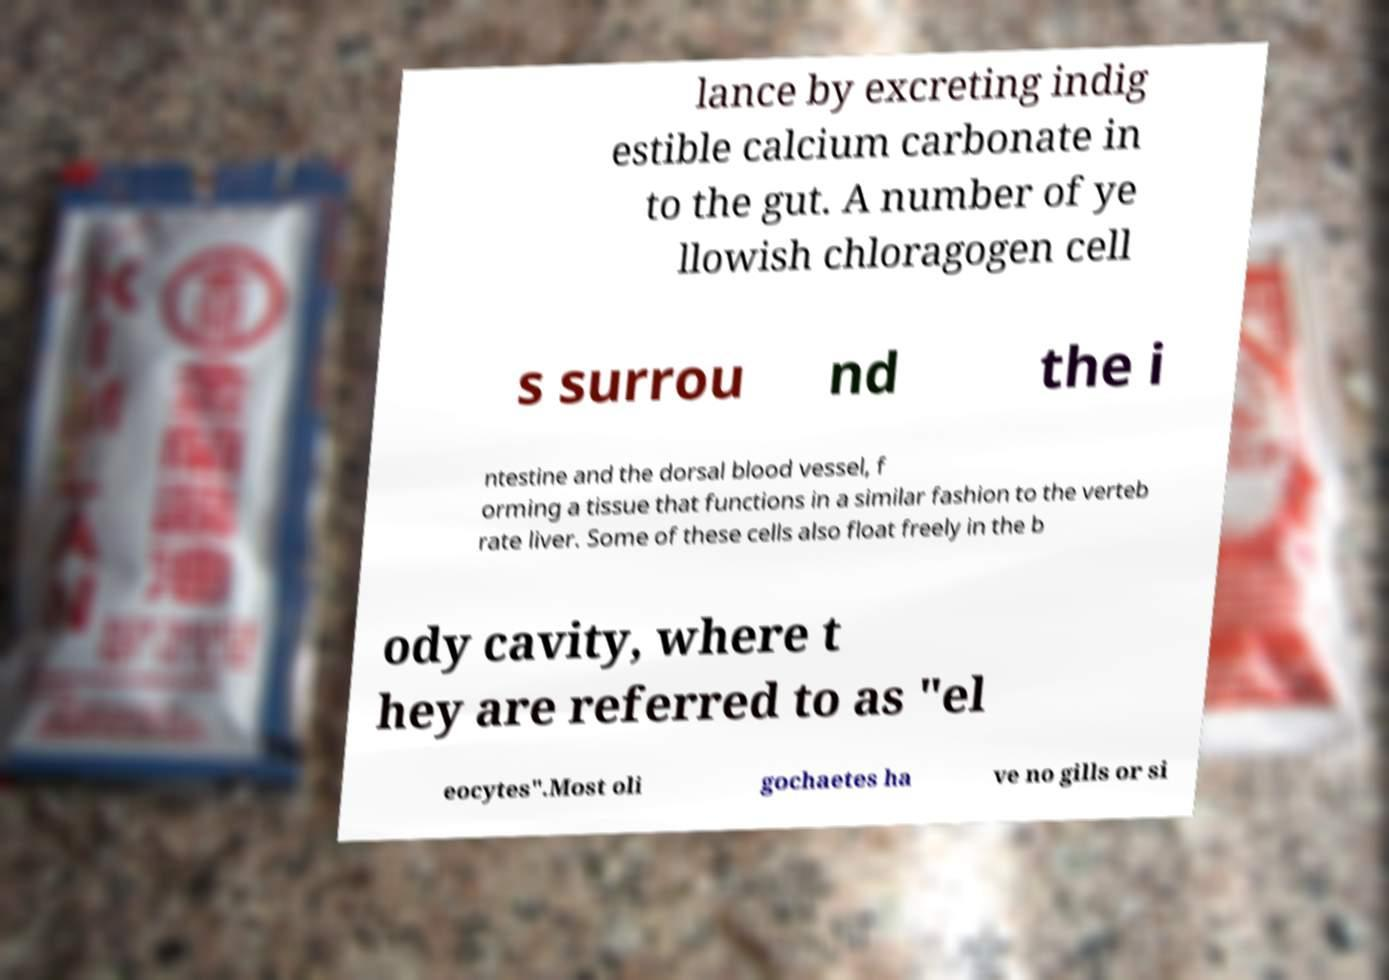I need the written content from this picture converted into text. Can you do that? lance by excreting indig estible calcium carbonate in to the gut. A number of ye llowish chloragogen cell s surrou nd the i ntestine and the dorsal blood vessel, f orming a tissue that functions in a similar fashion to the verteb rate liver. Some of these cells also float freely in the b ody cavity, where t hey are referred to as "el eocytes".Most oli gochaetes ha ve no gills or si 